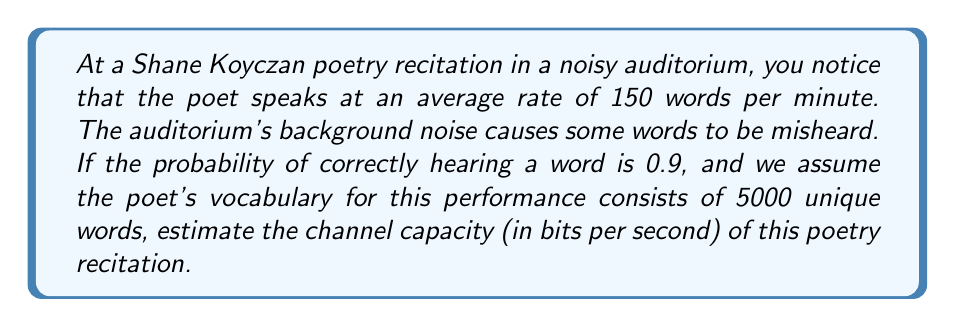Teach me how to tackle this problem. To solve this problem, we'll use Shannon's channel capacity formula and apply it to the context of a poetry recitation. Let's break it down step-by-step:

1) First, we need to calculate the information content of each word. Given a vocabulary of 5000 words, the information content of each word is:

   $H = \log_2(5000) \approx 12.29$ bits

2) The channel capacity formula is:

   $C = B \log_2(1 + S/N)$

   Where:
   $C$ is the channel capacity in bits per second
   $B$ is the bandwidth (in this case, words per second)
   $S/N$ is the signal-to-noise ratio

3) We're given that the poet speaks at 150 words per minute. Let's convert this to words per second:

   $B = 150 / 60 = 2.5$ words per second

4) The probability of correctly hearing a word (0.9) can be used to estimate the signal-to-noise ratio. If we consider the probability of error as the noise, then:

   $S/N = 0.9 / 0.1 = 9$

5) Now we can plug these values into the channel capacity formula:

   $C = 2.5 \log_2(1 + 9) \approx 8.27$ bits per second

6) However, this calculation assumes each word carries 1 bit of information. We need to adjust for the actual information content of each word:

   $C_{adjusted} = 8.27 * 12.29 \approx 101.64$ bits per second

This adjusted value represents the estimated channel capacity of the poetry recitation in the noisy auditorium.
Answer: The estimated channel capacity of the poetry recitation in the noisy auditorium is approximately 101.64 bits per second. 